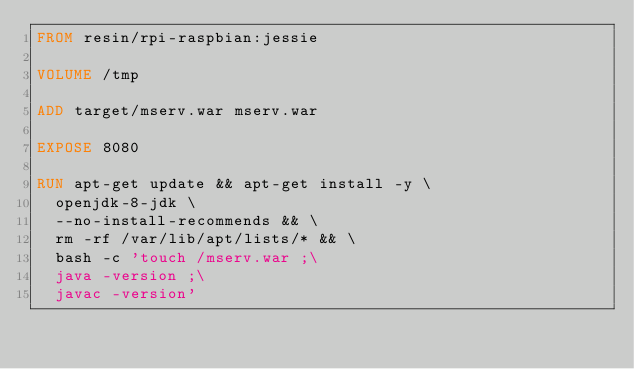Convert code to text. <code><loc_0><loc_0><loc_500><loc_500><_Dockerfile_>FROM resin/rpi-raspbian:jessie

VOLUME /tmp

ADD target/mserv.war mserv.war

EXPOSE 8080

RUN apt-get update && apt-get install -y \
	openjdk-8-jdk \
	--no-install-recommends && \
	rm -rf /var/lib/apt/lists/* && \
	bash -c 'touch /mserv.war ;\
	java -version ;\
	javac -version'
</code> 